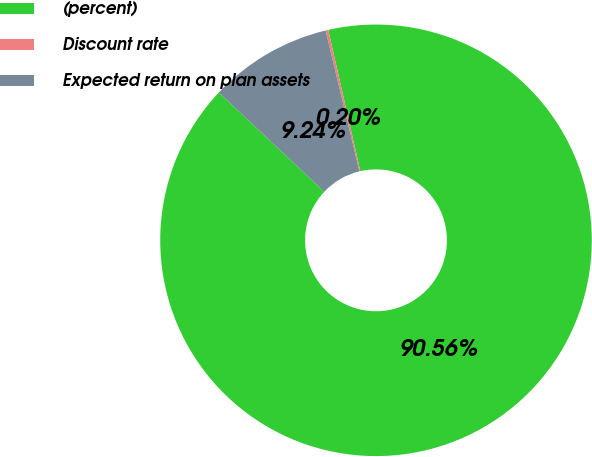Convert chart to OTSL. <chart><loc_0><loc_0><loc_500><loc_500><pie_chart><fcel>(percent)<fcel>Discount rate<fcel>Expected return on plan assets<nl><fcel>90.56%<fcel>0.2%<fcel>9.24%<nl></chart> 